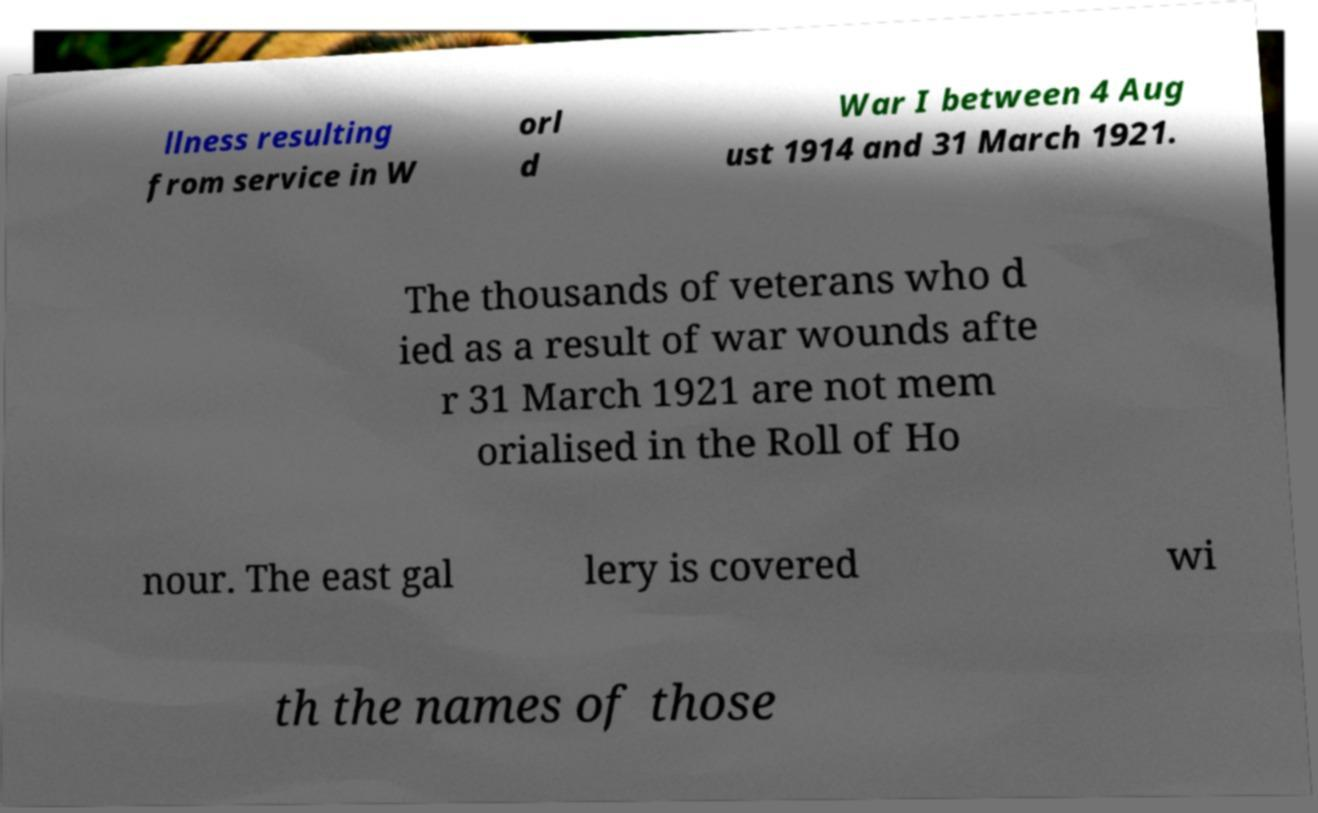What messages or text are displayed in this image? I need them in a readable, typed format. llness resulting from service in W orl d War I between 4 Aug ust 1914 and 31 March 1921. The thousands of veterans who d ied as a result of war wounds afte r 31 March 1921 are not mem orialised in the Roll of Ho nour. The east gal lery is covered wi th the names of those 